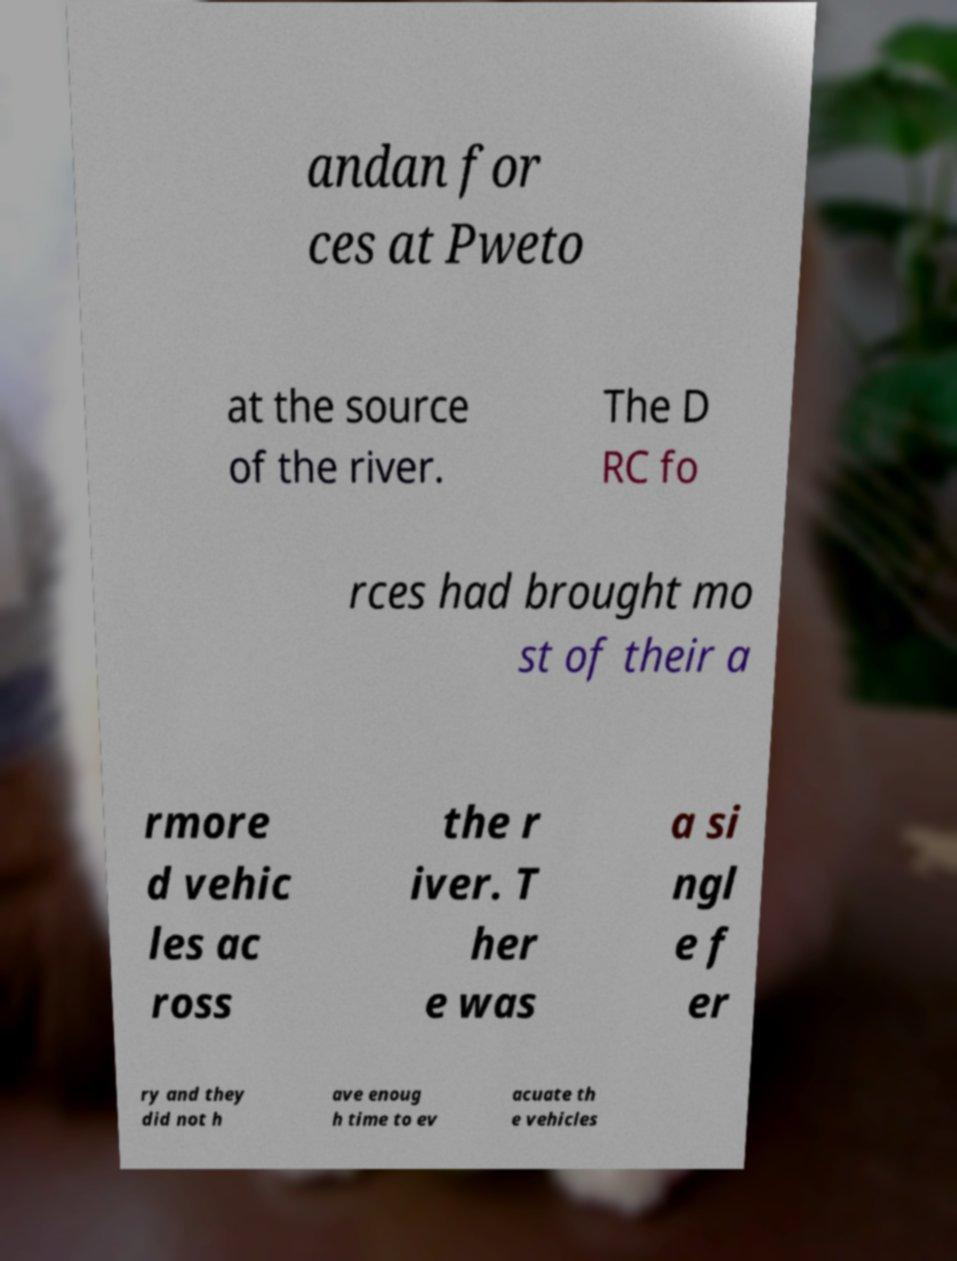Can you accurately transcribe the text from the provided image for me? andan for ces at Pweto at the source of the river. The D RC fo rces had brought mo st of their a rmore d vehic les ac ross the r iver. T her e was a si ngl e f er ry and they did not h ave enoug h time to ev acuate th e vehicles 